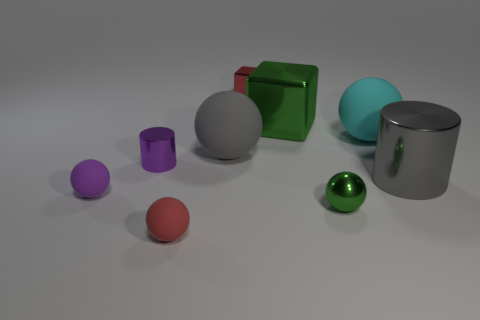Subtract all tiny purple balls. How many balls are left? 4 Subtract all brown spheres. Subtract all brown cubes. How many spheres are left? 5 Add 1 tiny metal blocks. How many objects exist? 10 Subtract all spheres. How many objects are left? 4 Subtract 1 cyan balls. How many objects are left? 8 Subtract all green objects. Subtract all yellow rubber balls. How many objects are left? 7 Add 6 purple things. How many purple things are left? 8 Add 5 small metal balls. How many small metal balls exist? 6 